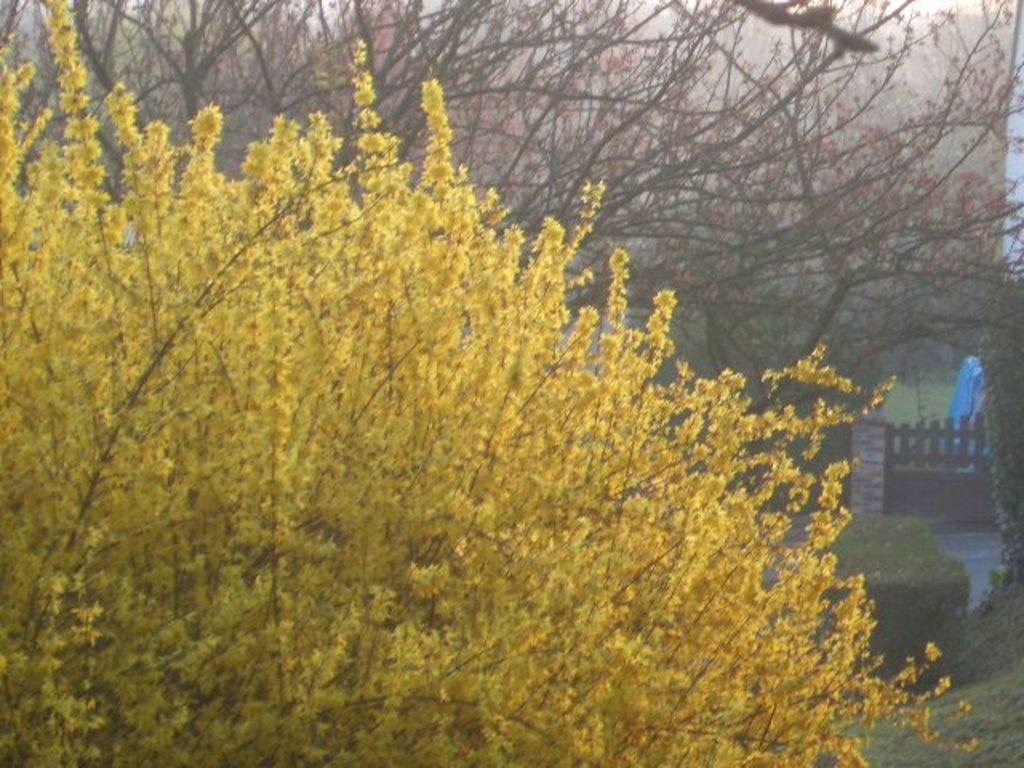Where was the picture taken? The picture was clicked outside. What can be seen in the foreground of the image? There are trees in the foreground of the image. What can be seen in the background of the image? There are plants and green grass in the background of the image. Can you describe any other items visible in the background of the image? There are other items visible in the background of the image, but their specific nature is not mentioned in the provided facts. How many girls are sitting on the roof in the image? There are no girls or roofs present in the image. 